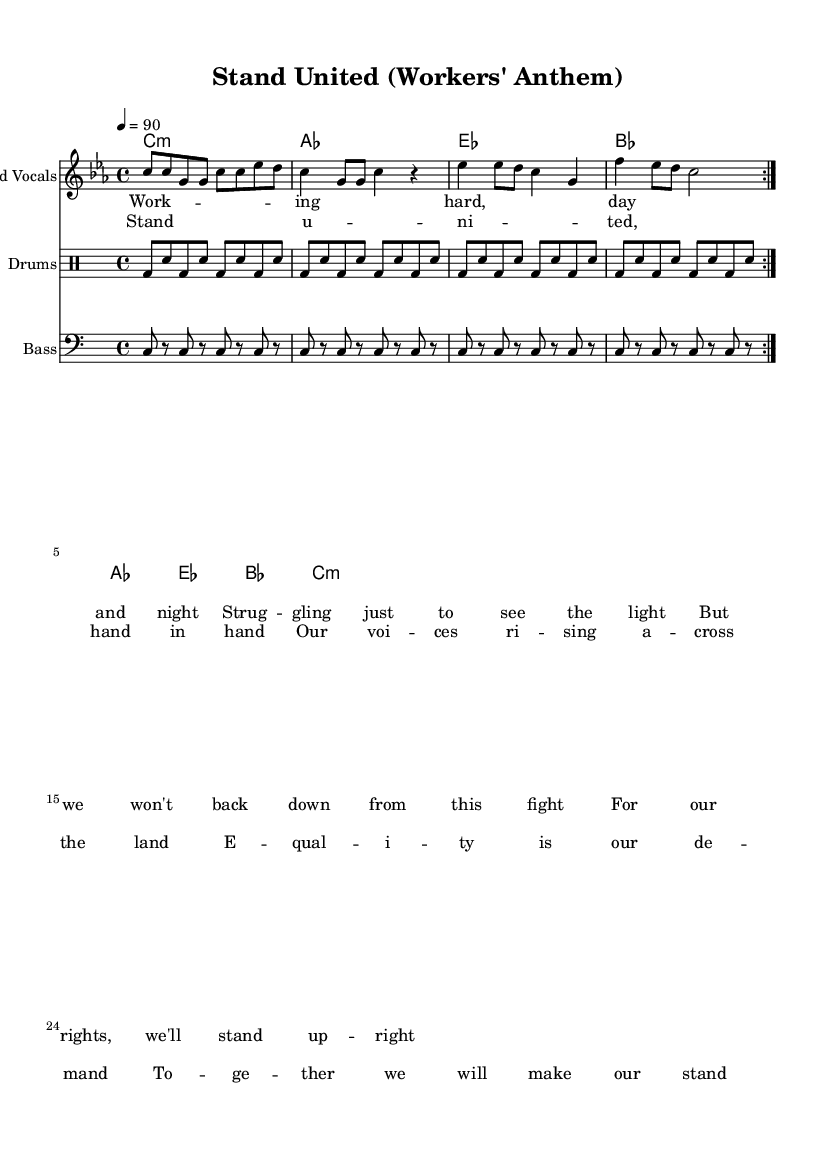What is the key signature of this music? The key signature is indicated by the absence of sharps or flats at the beginning of the staff, signifying it is in C minor.
Answer: C minor What is the time signature of this piece? The time signature is located after the clef sign and shows 4 over 4, indicating that there are four beats in each measure.
Answer: Four-four What is the tempo marking for this song? The tempo marking is provided in the code as "4 = 90," which translates to 90 beats per minute, guiding the overall speed of the piece.
Answer: Ninety How many measures are in the verse section? By counting the sections and repeated phrases in the verse lyrics aligned with the melodies, we find there are eight measures in total before reaching the chorus.
Answer: Eight What is the form of this song? The song follows a verse-chorus structure; it presents a verse followed by a repeated chorus to emphasize its message, which is a standard structure in rhythm and blues music.
Answer: Verse-chorus What rhythm patterns do the drums primarily feature? The drum part predominantly follows a kick-snare pattern repeated through the measures, creating a driving rhythm typical for R&B styles, reflecting a signature groove often found in such music.
Answer: Kick-snare What is the primary theme of the lyrics? The lyrics focus on solidarity and empowerment, discussing workers' rights and collective action, which is a central message in the genre of workers' anthems and R&B.
Answer: Workers' rights 